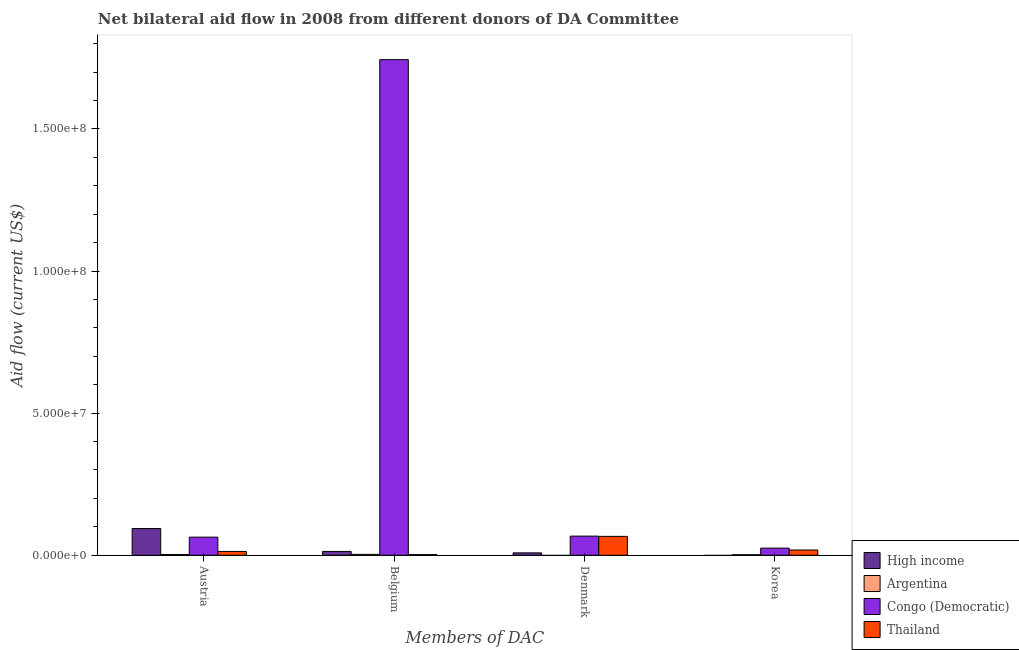How many different coloured bars are there?
Keep it short and to the point. 4. Are the number of bars per tick equal to the number of legend labels?
Your answer should be compact. No. Are the number of bars on each tick of the X-axis equal?
Provide a succinct answer. No. How many bars are there on the 1st tick from the right?
Offer a very short reply. 3. What is the amount of aid given by korea in Argentina?
Offer a very short reply. 1.80e+05. Across all countries, what is the maximum amount of aid given by belgium?
Keep it short and to the point. 1.74e+08. Across all countries, what is the minimum amount of aid given by belgium?
Your answer should be very brief. 2.40e+05. In which country was the amount of aid given by belgium maximum?
Your answer should be very brief. Congo (Democratic). What is the total amount of aid given by austria in the graph?
Your response must be concise. 1.74e+07. What is the difference between the amount of aid given by belgium in Argentina and that in High income?
Offer a terse response. -1.03e+06. What is the difference between the amount of aid given by belgium in Thailand and the amount of aid given by korea in Congo (Democratic)?
Your answer should be compact. -2.27e+06. What is the average amount of aid given by austria per country?
Ensure brevity in your answer.  4.35e+06. What is the difference between the amount of aid given by korea and amount of aid given by austria in Thailand?
Your answer should be very brief. 5.10e+05. In how many countries, is the amount of aid given by korea greater than 10000000 US$?
Keep it short and to the point. 0. What is the ratio of the amount of aid given by austria in Congo (Democratic) to that in High income?
Your answer should be compact. 0.68. What is the difference between the highest and the lowest amount of aid given by denmark?
Your answer should be compact. 6.73e+06. In how many countries, is the amount of aid given by korea greater than the average amount of aid given by korea taken over all countries?
Ensure brevity in your answer.  2. Is the sum of the amount of aid given by korea in Thailand and Argentina greater than the maximum amount of aid given by belgium across all countries?
Ensure brevity in your answer.  No. Is it the case that in every country, the sum of the amount of aid given by austria and amount of aid given by belgium is greater than the amount of aid given by denmark?
Provide a short and direct response. No. How many bars are there?
Provide a succinct answer. 14. What is the difference between two consecutive major ticks on the Y-axis?
Provide a short and direct response. 5.00e+07. Does the graph contain any zero values?
Offer a terse response. Yes. Does the graph contain grids?
Provide a short and direct response. No. How many legend labels are there?
Provide a short and direct response. 4. How are the legend labels stacked?
Your answer should be compact. Vertical. What is the title of the graph?
Your answer should be compact. Net bilateral aid flow in 2008 from different donors of DA Committee. What is the label or title of the X-axis?
Provide a succinct answer. Members of DAC. What is the label or title of the Y-axis?
Ensure brevity in your answer.  Aid flow (current US$). What is the Aid flow (current US$) of High income in Austria?
Give a very brief answer. 9.41e+06. What is the Aid flow (current US$) in Congo (Democratic) in Austria?
Offer a very short reply. 6.38e+06. What is the Aid flow (current US$) of Thailand in Austria?
Keep it short and to the point. 1.34e+06. What is the Aid flow (current US$) in High income in Belgium?
Give a very brief answer. 1.35e+06. What is the Aid flow (current US$) of Congo (Democratic) in Belgium?
Your answer should be very brief. 1.74e+08. What is the Aid flow (current US$) of High income in Denmark?
Offer a very short reply. 8.40e+05. What is the Aid flow (current US$) in Argentina in Denmark?
Your answer should be very brief. 0. What is the Aid flow (current US$) of Congo (Democratic) in Denmark?
Your answer should be very brief. 6.73e+06. What is the Aid flow (current US$) of Thailand in Denmark?
Your response must be concise. 6.65e+06. What is the Aid flow (current US$) in Argentina in Korea?
Provide a succinct answer. 1.80e+05. What is the Aid flow (current US$) in Congo (Democratic) in Korea?
Your answer should be compact. 2.51e+06. What is the Aid flow (current US$) of Thailand in Korea?
Provide a short and direct response. 1.85e+06. Across all Members of DAC, what is the maximum Aid flow (current US$) in High income?
Make the answer very short. 9.41e+06. Across all Members of DAC, what is the maximum Aid flow (current US$) of Argentina?
Offer a very short reply. 3.20e+05. Across all Members of DAC, what is the maximum Aid flow (current US$) in Congo (Democratic)?
Your response must be concise. 1.74e+08. Across all Members of DAC, what is the maximum Aid flow (current US$) of Thailand?
Your answer should be very brief. 6.65e+06. Across all Members of DAC, what is the minimum Aid flow (current US$) in High income?
Offer a terse response. 0. Across all Members of DAC, what is the minimum Aid flow (current US$) of Argentina?
Offer a very short reply. 0. Across all Members of DAC, what is the minimum Aid flow (current US$) in Congo (Democratic)?
Your answer should be very brief. 2.51e+06. Across all Members of DAC, what is the minimum Aid flow (current US$) of Thailand?
Offer a terse response. 2.40e+05. What is the total Aid flow (current US$) in High income in the graph?
Keep it short and to the point. 1.16e+07. What is the total Aid flow (current US$) in Argentina in the graph?
Give a very brief answer. 7.70e+05. What is the total Aid flow (current US$) of Congo (Democratic) in the graph?
Your response must be concise. 1.90e+08. What is the total Aid flow (current US$) of Thailand in the graph?
Offer a very short reply. 1.01e+07. What is the difference between the Aid flow (current US$) in High income in Austria and that in Belgium?
Offer a very short reply. 8.06e+06. What is the difference between the Aid flow (current US$) of Congo (Democratic) in Austria and that in Belgium?
Provide a short and direct response. -1.68e+08. What is the difference between the Aid flow (current US$) in Thailand in Austria and that in Belgium?
Give a very brief answer. 1.10e+06. What is the difference between the Aid flow (current US$) in High income in Austria and that in Denmark?
Your response must be concise. 8.57e+06. What is the difference between the Aid flow (current US$) of Congo (Democratic) in Austria and that in Denmark?
Ensure brevity in your answer.  -3.50e+05. What is the difference between the Aid flow (current US$) of Thailand in Austria and that in Denmark?
Ensure brevity in your answer.  -5.31e+06. What is the difference between the Aid flow (current US$) in Congo (Democratic) in Austria and that in Korea?
Provide a short and direct response. 3.87e+06. What is the difference between the Aid flow (current US$) of Thailand in Austria and that in Korea?
Provide a short and direct response. -5.10e+05. What is the difference between the Aid flow (current US$) of High income in Belgium and that in Denmark?
Provide a succinct answer. 5.10e+05. What is the difference between the Aid flow (current US$) of Congo (Democratic) in Belgium and that in Denmark?
Provide a short and direct response. 1.68e+08. What is the difference between the Aid flow (current US$) of Thailand in Belgium and that in Denmark?
Offer a terse response. -6.41e+06. What is the difference between the Aid flow (current US$) in Argentina in Belgium and that in Korea?
Offer a very short reply. 1.40e+05. What is the difference between the Aid flow (current US$) in Congo (Democratic) in Belgium and that in Korea?
Provide a succinct answer. 1.72e+08. What is the difference between the Aid flow (current US$) in Thailand in Belgium and that in Korea?
Your answer should be very brief. -1.61e+06. What is the difference between the Aid flow (current US$) in Congo (Democratic) in Denmark and that in Korea?
Ensure brevity in your answer.  4.22e+06. What is the difference between the Aid flow (current US$) in Thailand in Denmark and that in Korea?
Ensure brevity in your answer.  4.80e+06. What is the difference between the Aid flow (current US$) in High income in Austria and the Aid flow (current US$) in Argentina in Belgium?
Give a very brief answer. 9.09e+06. What is the difference between the Aid flow (current US$) of High income in Austria and the Aid flow (current US$) of Congo (Democratic) in Belgium?
Your response must be concise. -1.65e+08. What is the difference between the Aid flow (current US$) of High income in Austria and the Aid flow (current US$) of Thailand in Belgium?
Ensure brevity in your answer.  9.17e+06. What is the difference between the Aid flow (current US$) of Argentina in Austria and the Aid flow (current US$) of Congo (Democratic) in Belgium?
Your response must be concise. -1.74e+08. What is the difference between the Aid flow (current US$) of Argentina in Austria and the Aid flow (current US$) of Thailand in Belgium?
Ensure brevity in your answer.  3.00e+04. What is the difference between the Aid flow (current US$) of Congo (Democratic) in Austria and the Aid flow (current US$) of Thailand in Belgium?
Your answer should be very brief. 6.14e+06. What is the difference between the Aid flow (current US$) of High income in Austria and the Aid flow (current US$) of Congo (Democratic) in Denmark?
Offer a very short reply. 2.68e+06. What is the difference between the Aid flow (current US$) of High income in Austria and the Aid flow (current US$) of Thailand in Denmark?
Make the answer very short. 2.76e+06. What is the difference between the Aid flow (current US$) in Argentina in Austria and the Aid flow (current US$) in Congo (Democratic) in Denmark?
Ensure brevity in your answer.  -6.46e+06. What is the difference between the Aid flow (current US$) of Argentina in Austria and the Aid flow (current US$) of Thailand in Denmark?
Give a very brief answer. -6.38e+06. What is the difference between the Aid flow (current US$) in Congo (Democratic) in Austria and the Aid flow (current US$) in Thailand in Denmark?
Offer a very short reply. -2.70e+05. What is the difference between the Aid flow (current US$) of High income in Austria and the Aid flow (current US$) of Argentina in Korea?
Keep it short and to the point. 9.23e+06. What is the difference between the Aid flow (current US$) of High income in Austria and the Aid flow (current US$) of Congo (Democratic) in Korea?
Give a very brief answer. 6.90e+06. What is the difference between the Aid flow (current US$) of High income in Austria and the Aid flow (current US$) of Thailand in Korea?
Offer a terse response. 7.56e+06. What is the difference between the Aid flow (current US$) of Argentina in Austria and the Aid flow (current US$) of Congo (Democratic) in Korea?
Your answer should be compact. -2.24e+06. What is the difference between the Aid flow (current US$) of Argentina in Austria and the Aid flow (current US$) of Thailand in Korea?
Provide a succinct answer. -1.58e+06. What is the difference between the Aid flow (current US$) in Congo (Democratic) in Austria and the Aid flow (current US$) in Thailand in Korea?
Offer a very short reply. 4.53e+06. What is the difference between the Aid flow (current US$) of High income in Belgium and the Aid flow (current US$) of Congo (Democratic) in Denmark?
Ensure brevity in your answer.  -5.38e+06. What is the difference between the Aid flow (current US$) of High income in Belgium and the Aid flow (current US$) of Thailand in Denmark?
Your answer should be compact. -5.30e+06. What is the difference between the Aid flow (current US$) of Argentina in Belgium and the Aid flow (current US$) of Congo (Democratic) in Denmark?
Your answer should be compact. -6.41e+06. What is the difference between the Aid flow (current US$) of Argentina in Belgium and the Aid flow (current US$) of Thailand in Denmark?
Provide a short and direct response. -6.33e+06. What is the difference between the Aid flow (current US$) in Congo (Democratic) in Belgium and the Aid flow (current US$) in Thailand in Denmark?
Provide a short and direct response. 1.68e+08. What is the difference between the Aid flow (current US$) in High income in Belgium and the Aid flow (current US$) in Argentina in Korea?
Your response must be concise. 1.17e+06. What is the difference between the Aid flow (current US$) of High income in Belgium and the Aid flow (current US$) of Congo (Democratic) in Korea?
Offer a terse response. -1.16e+06. What is the difference between the Aid flow (current US$) of High income in Belgium and the Aid flow (current US$) of Thailand in Korea?
Your answer should be compact. -5.00e+05. What is the difference between the Aid flow (current US$) of Argentina in Belgium and the Aid flow (current US$) of Congo (Democratic) in Korea?
Your answer should be very brief. -2.19e+06. What is the difference between the Aid flow (current US$) in Argentina in Belgium and the Aid flow (current US$) in Thailand in Korea?
Ensure brevity in your answer.  -1.53e+06. What is the difference between the Aid flow (current US$) in Congo (Democratic) in Belgium and the Aid flow (current US$) in Thailand in Korea?
Offer a terse response. 1.73e+08. What is the difference between the Aid flow (current US$) in High income in Denmark and the Aid flow (current US$) in Congo (Democratic) in Korea?
Give a very brief answer. -1.67e+06. What is the difference between the Aid flow (current US$) of High income in Denmark and the Aid flow (current US$) of Thailand in Korea?
Give a very brief answer. -1.01e+06. What is the difference between the Aid flow (current US$) of Congo (Democratic) in Denmark and the Aid flow (current US$) of Thailand in Korea?
Give a very brief answer. 4.88e+06. What is the average Aid flow (current US$) of High income per Members of DAC?
Offer a very short reply. 2.90e+06. What is the average Aid flow (current US$) of Argentina per Members of DAC?
Offer a terse response. 1.92e+05. What is the average Aid flow (current US$) of Congo (Democratic) per Members of DAC?
Keep it short and to the point. 4.75e+07. What is the average Aid flow (current US$) of Thailand per Members of DAC?
Give a very brief answer. 2.52e+06. What is the difference between the Aid flow (current US$) of High income and Aid flow (current US$) of Argentina in Austria?
Your answer should be compact. 9.14e+06. What is the difference between the Aid flow (current US$) in High income and Aid flow (current US$) in Congo (Democratic) in Austria?
Your response must be concise. 3.03e+06. What is the difference between the Aid flow (current US$) in High income and Aid flow (current US$) in Thailand in Austria?
Your answer should be very brief. 8.07e+06. What is the difference between the Aid flow (current US$) in Argentina and Aid flow (current US$) in Congo (Democratic) in Austria?
Keep it short and to the point. -6.11e+06. What is the difference between the Aid flow (current US$) in Argentina and Aid flow (current US$) in Thailand in Austria?
Keep it short and to the point. -1.07e+06. What is the difference between the Aid flow (current US$) of Congo (Democratic) and Aid flow (current US$) of Thailand in Austria?
Ensure brevity in your answer.  5.04e+06. What is the difference between the Aid flow (current US$) in High income and Aid flow (current US$) in Argentina in Belgium?
Make the answer very short. 1.03e+06. What is the difference between the Aid flow (current US$) of High income and Aid flow (current US$) of Congo (Democratic) in Belgium?
Give a very brief answer. -1.73e+08. What is the difference between the Aid flow (current US$) in High income and Aid flow (current US$) in Thailand in Belgium?
Your answer should be compact. 1.11e+06. What is the difference between the Aid flow (current US$) in Argentina and Aid flow (current US$) in Congo (Democratic) in Belgium?
Provide a short and direct response. -1.74e+08. What is the difference between the Aid flow (current US$) of Congo (Democratic) and Aid flow (current US$) of Thailand in Belgium?
Provide a short and direct response. 1.74e+08. What is the difference between the Aid flow (current US$) of High income and Aid flow (current US$) of Congo (Democratic) in Denmark?
Provide a succinct answer. -5.89e+06. What is the difference between the Aid flow (current US$) in High income and Aid flow (current US$) in Thailand in Denmark?
Offer a terse response. -5.81e+06. What is the difference between the Aid flow (current US$) of Congo (Democratic) and Aid flow (current US$) of Thailand in Denmark?
Your answer should be very brief. 8.00e+04. What is the difference between the Aid flow (current US$) in Argentina and Aid flow (current US$) in Congo (Democratic) in Korea?
Make the answer very short. -2.33e+06. What is the difference between the Aid flow (current US$) in Argentina and Aid flow (current US$) in Thailand in Korea?
Provide a succinct answer. -1.67e+06. What is the difference between the Aid flow (current US$) of Congo (Democratic) and Aid flow (current US$) of Thailand in Korea?
Your response must be concise. 6.60e+05. What is the ratio of the Aid flow (current US$) of High income in Austria to that in Belgium?
Provide a short and direct response. 6.97. What is the ratio of the Aid flow (current US$) of Argentina in Austria to that in Belgium?
Your response must be concise. 0.84. What is the ratio of the Aid flow (current US$) of Congo (Democratic) in Austria to that in Belgium?
Give a very brief answer. 0.04. What is the ratio of the Aid flow (current US$) in Thailand in Austria to that in Belgium?
Provide a short and direct response. 5.58. What is the ratio of the Aid flow (current US$) in High income in Austria to that in Denmark?
Provide a succinct answer. 11.2. What is the ratio of the Aid flow (current US$) of Congo (Democratic) in Austria to that in Denmark?
Give a very brief answer. 0.95. What is the ratio of the Aid flow (current US$) in Thailand in Austria to that in Denmark?
Offer a very short reply. 0.2. What is the ratio of the Aid flow (current US$) of Congo (Democratic) in Austria to that in Korea?
Your answer should be compact. 2.54. What is the ratio of the Aid flow (current US$) in Thailand in Austria to that in Korea?
Give a very brief answer. 0.72. What is the ratio of the Aid flow (current US$) of High income in Belgium to that in Denmark?
Give a very brief answer. 1.61. What is the ratio of the Aid flow (current US$) of Congo (Democratic) in Belgium to that in Denmark?
Offer a terse response. 25.91. What is the ratio of the Aid flow (current US$) in Thailand in Belgium to that in Denmark?
Ensure brevity in your answer.  0.04. What is the ratio of the Aid flow (current US$) of Argentina in Belgium to that in Korea?
Offer a very short reply. 1.78. What is the ratio of the Aid flow (current US$) in Congo (Democratic) in Belgium to that in Korea?
Provide a succinct answer. 69.47. What is the ratio of the Aid flow (current US$) in Thailand in Belgium to that in Korea?
Give a very brief answer. 0.13. What is the ratio of the Aid flow (current US$) in Congo (Democratic) in Denmark to that in Korea?
Make the answer very short. 2.68. What is the ratio of the Aid flow (current US$) of Thailand in Denmark to that in Korea?
Offer a very short reply. 3.59. What is the difference between the highest and the second highest Aid flow (current US$) of High income?
Ensure brevity in your answer.  8.06e+06. What is the difference between the highest and the second highest Aid flow (current US$) in Argentina?
Provide a succinct answer. 5.00e+04. What is the difference between the highest and the second highest Aid flow (current US$) in Congo (Democratic)?
Offer a terse response. 1.68e+08. What is the difference between the highest and the second highest Aid flow (current US$) of Thailand?
Keep it short and to the point. 4.80e+06. What is the difference between the highest and the lowest Aid flow (current US$) of High income?
Provide a short and direct response. 9.41e+06. What is the difference between the highest and the lowest Aid flow (current US$) in Argentina?
Offer a terse response. 3.20e+05. What is the difference between the highest and the lowest Aid flow (current US$) of Congo (Democratic)?
Give a very brief answer. 1.72e+08. What is the difference between the highest and the lowest Aid flow (current US$) of Thailand?
Ensure brevity in your answer.  6.41e+06. 